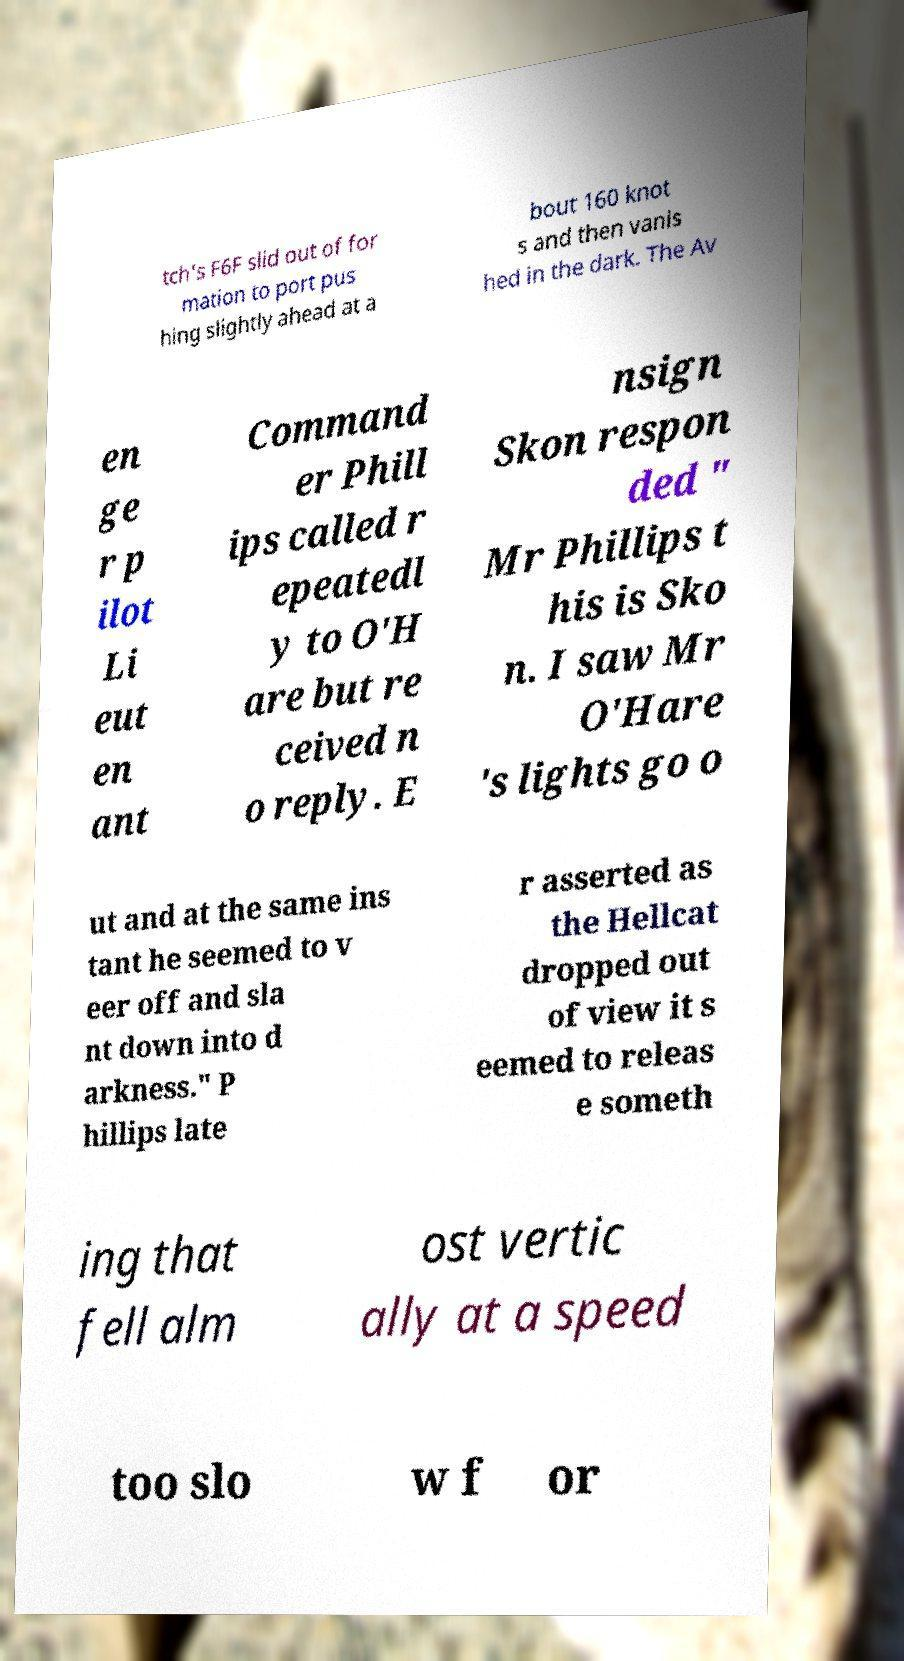There's text embedded in this image that I need extracted. Can you transcribe it verbatim? tch's F6F slid out of for mation to port pus hing slightly ahead at a bout 160 knot s and then vanis hed in the dark. The Av en ge r p ilot Li eut en ant Command er Phill ips called r epeatedl y to O'H are but re ceived n o reply. E nsign Skon respon ded " Mr Phillips t his is Sko n. I saw Mr O'Hare 's lights go o ut and at the same ins tant he seemed to v eer off and sla nt down into d arkness." P hillips late r asserted as the Hellcat dropped out of view it s eemed to releas e someth ing that fell alm ost vertic ally at a speed too slo w f or 